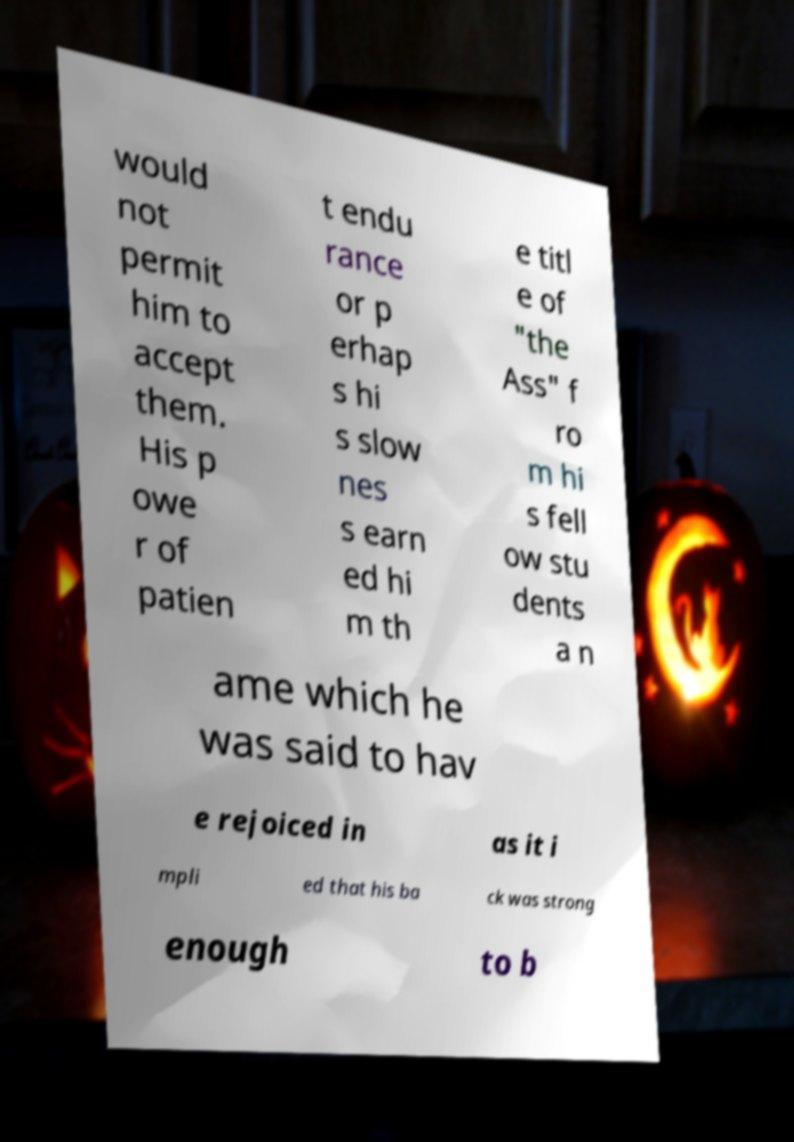Please identify and transcribe the text found in this image. would not permit him to accept them. His p owe r of patien t endu rance or p erhap s hi s slow nes s earn ed hi m th e titl e of "the Ass" f ro m hi s fell ow stu dents a n ame which he was said to hav e rejoiced in as it i mpli ed that his ba ck was strong enough to b 